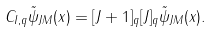<formula> <loc_0><loc_0><loc_500><loc_500>C _ { I , q } \tilde { \psi } _ { J M } ( { x } ) = [ J + 1 ] _ { q } [ J ] _ { q } \tilde { \psi } _ { J M } ( { x } ) .</formula> 